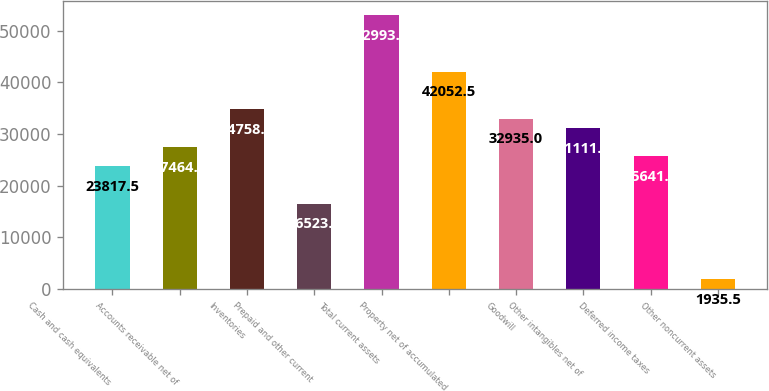Convert chart. <chart><loc_0><loc_0><loc_500><loc_500><bar_chart><fcel>Cash and cash equivalents<fcel>Accounts receivable net of<fcel>Inventories<fcel>Prepaid and other current<fcel>Total current assets<fcel>Property net of accumulated<fcel>Goodwill<fcel>Other intangibles net of<fcel>Deferred income taxes<fcel>Other noncurrent assets<nl><fcel>23817.5<fcel>27464.5<fcel>34758.5<fcel>16523.5<fcel>52993.5<fcel>42052.5<fcel>32935<fcel>31111.5<fcel>25641<fcel>1935.5<nl></chart> 